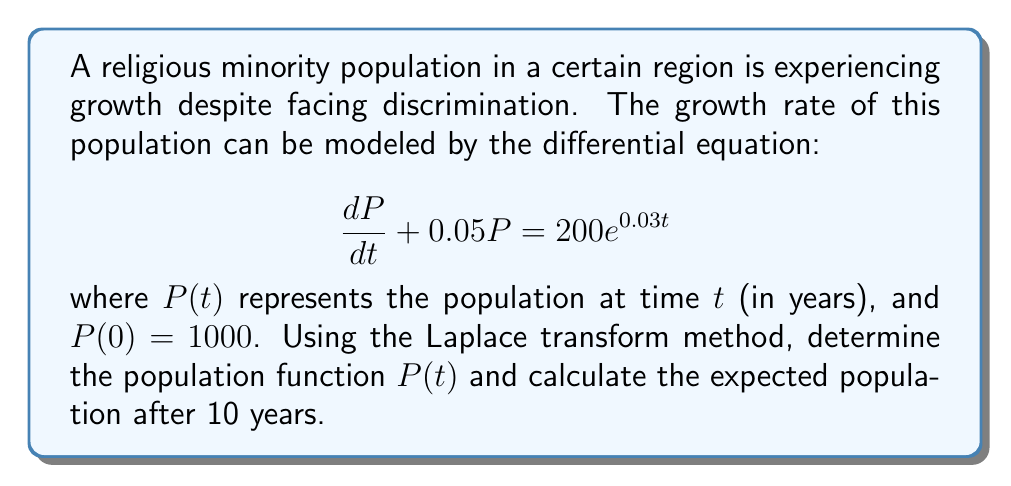Solve this math problem. To solve this problem using the Laplace transform method, we'll follow these steps:

1) Take the Laplace transform of both sides of the differential equation:
   $$\mathcal{L}\left\{\frac{dP}{dt} + 0.05P\right\} = \mathcal{L}\{200e^{0.03t}\}$$

2) Using Laplace transform properties:
   $$sP(s) - P(0) + 0.05P(s) = \frac{200}{s-0.03}$$

3) Substitute the initial condition $P(0) = 1000$:
   $$sP(s) - 1000 + 0.05P(s) = \frac{200}{s-0.03}$$

4) Solve for $P(s)$:
   $$(s + 0.05)P(s) = \frac{200}{s-0.03} + 1000$$
   $$P(s) = \frac{200}{(s-0.03)(s+0.05)} + \frac{1000}{s+0.05}$$

5) Decompose into partial fractions:
   $$P(s) = \frac{A}{s-0.03} + \frac{B}{s+0.05} + \frac{1000}{s+0.05}$$
   
   where $A = \frac{200}{0.08} = 2500$ and $B = -\frac{200}{0.08} = -2500$

6) Take the inverse Laplace transform:
   $$P(t) = 2500e^{0.03t} - 2500e^{-0.05t} + 1000e^{-0.05t}$$
   $$P(t) = 2500e^{0.03t} - 1500e^{-0.05t}$$

7) To find the population after 10 years, substitute $t = 10$:
   $$P(10) = 2500e^{0.3} - 1500e^{-0.5}$$
   $$P(10) \approx 3373.39 - 908.42 = 2464.97$$
Answer: The population function is $P(t) = 2500e^{0.03t} - 1500e^{-0.05t}$, and the expected population after 10 years is approximately 2465 individuals. 